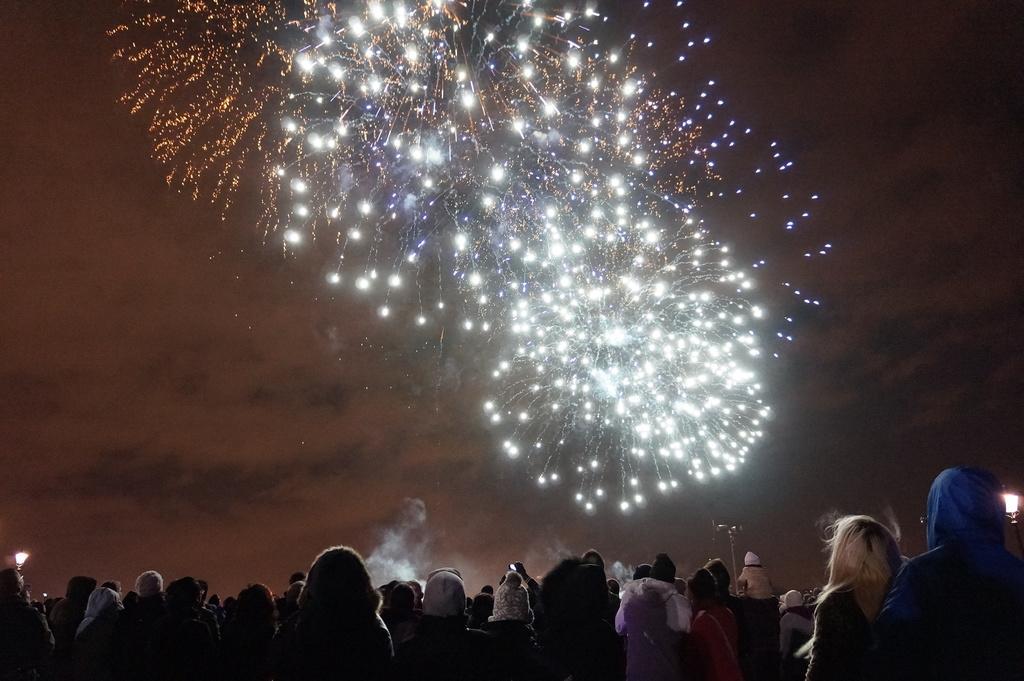Describe this image in one or two sentences. At the bottom of the image we can see people standing. There are poles and lights. In the background we can see fireworks in the sky. 